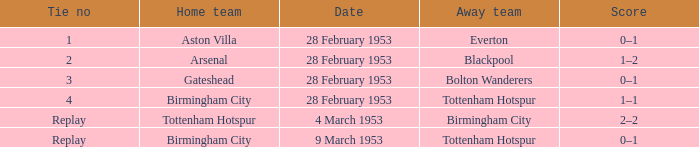Which Tie no has a Score of 0–1, and a Date of 9 march 1953? Replay. 